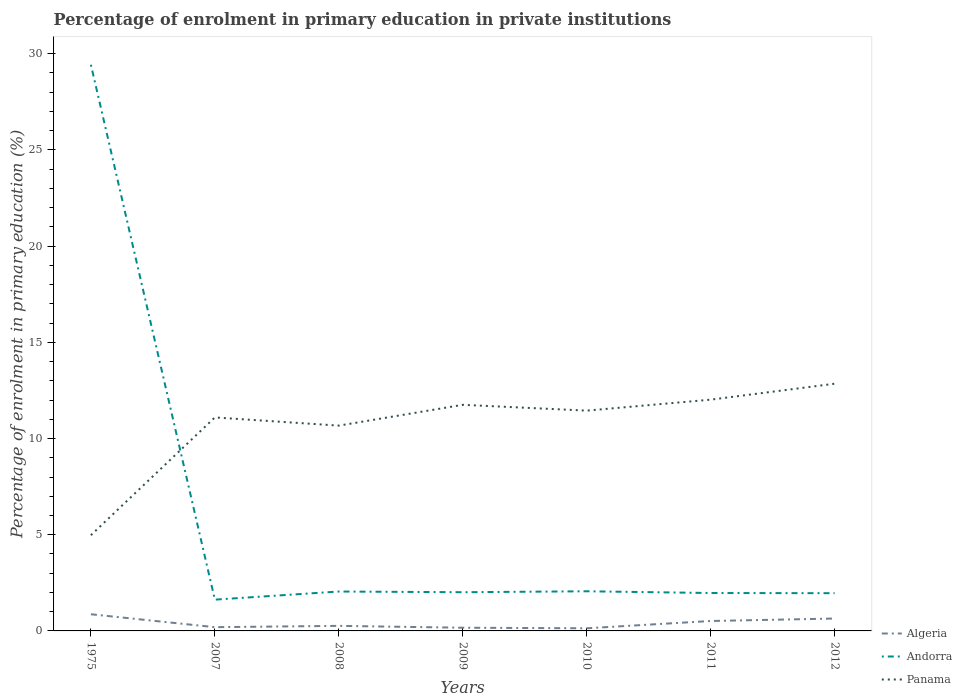Across all years, what is the maximum percentage of enrolment in primary education in Panama?
Your answer should be very brief. 4.98. In which year was the percentage of enrolment in primary education in Panama maximum?
Offer a very short reply. 1975. What is the total percentage of enrolment in primary education in Algeria in the graph?
Make the answer very short. -0.38. What is the difference between the highest and the second highest percentage of enrolment in primary education in Andorra?
Your answer should be compact. 27.8. What is the difference between the highest and the lowest percentage of enrolment in primary education in Panama?
Offer a very short reply. 5. Is the percentage of enrolment in primary education in Panama strictly greater than the percentage of enrolment in primary education in Algeria over the years?
Provide a succinct answer. No. Does the graph contain any zero values?
Make the answer very short. No. Does the graph contain grids?
Keep it short and to the point. No. Where does the legend appear in the graph?
Your response must be concise. Bottom right. What is the title of the graph?
Provide a short and direct response. Percentage of enrolment in primary education in private institutions. What is the label or title of the Y-axis?
Ensure brevity in your answer.  Percentage of enrolment in primary education (%). What is the Percentage of enrolment in primary education (%) in Algeria in 1975?
Ensure brevity in your answer.  0.87. What is the Percentage of enrolment in primary education (%) in Andorra in 1975?
Provide a succinct answer. 29.43. What is the Percentage of enrolment in primary education (%) in Panama in 1975?
Your answer should be compact. 4.98. What is the Percentage of enrolment in primary education (%) of Algeria in 2007?
Make the answer very short. 0.2. What is the Percentage of enrolment in primary education (%) in Andorra in 2007?
Keep it short and to the point. 1.63. What is the Percentage of enrolment in primary education (%) in Panama in 2007?
Give a very brief answer. 11.1. What is the Percentage of enrolment in primary education (%) of Algeria in 2008?
Ensure brevity in your answer.  0.26. What is the Percentage of enrolment in primary education (%) of Andorra in 2008?
Make the answer very short. 2.05. What is the Percentage of enrolment in primary education (%) in Panama in 2008?
Offer a very short reply. 10.67. What is the Percentage of enrolment in primary education (%) in Algeria in 2009?
Provide a short and direct response. 0.17. What is the Percentage of enrolment in primary education (%) of Andorra in 2009?
Your answer should be very brief. 2.01. What is the Percentage of enrolment in primary education (%) in Panama in 2009?
Provide a short and direct response. 11.75. What is the Percentage of enrolment in primary education (%) of Algeria in 2010?
Provide a succinct answer. 0.14. What is the Percentage of enrolment in primary education (%) in Andorra in 2010?
Keep it short and to the point. 2.06. What is the Percentage of enrolment in primary education (%) of Panama in 2010?
Your answer should be compact. 11.45. What is the Percentage of enrolment in primary education (%) in Algeria in 2011?
Your response must be concise. 0.52. What is the Percentage of enrolment in primary education (%) in Andorra in 2011?
Ensure brevity in your answer.  1.97. What is the Percentage of enrolment in primary education (%) of Panama in 2011?
Provide a succinct answer. 12.02. What is the Percentage of enrolment in primary education (%) of Algeria in 2012?
Keep it short and to the point. 0.64. What is the Percentage of enrolment in primary education (%) in Andorra in 2012?
Provide a succinct answer. 1.96. What is the Percentage of enrolment in primary education (%) in Panama in 2012?
Provide a succinct answer. 12.85. Across all years, what is the maximum Percentage of enrolment in primary education (%) in Algeria?
Offer a very short reply. 0.87. Across all years, what is the maximum Percentage of enrolment in primary education (%) in Andorra?
Your response must be concise. 29.43. Across all years, what is the maximum Percentage of enrolment in primary education (%) of Panama?
Offer a terse response. 12.85. Across all years, what is the minimum Percentage of enrolment in primary education (%) of Algeria?
Your response must be concise. 0.14. Across all years, what is the minimum Percentage of enrolment in primary education (%) of Andorra?
Keep it short and to the point. 1.63. Across all years, what is the minimum Percentage of enrolment in primary education (%) of Panama?
Your response must be concise. 4.98. What is the total Percentage of enrolment in primary education (%) of Algeria in the graph?
Provide a succinct answer. 2.79. What is the total Percentage of enrolment in primary education (%) in Andorra in the graph?
Your answer should be very brief. 41.11. What is the total Percentage of enrolment in primary education (%) of Panama in the graph?
Your answer should be compact. 74.82. What is the difference between the Percentage of enrolment in primary education (%) of Algeria in 1975 and that in 2007?
Your answer should be very brief. 0.67. What is the difference between the Percentage of enrolment in primary education (%) of Andorra in 1975 and that in 2007?
Your answer should be very brief. 27.8. What is the difference between the Percentage of enrolment in primary education (%) of Panama in 1975 and that in 2007?
Offer a very short reply. -6.12. What is the difference between the Percentage of enrolment in primary education (%) of Algeria in 1975 and that in 2008?
Offer a terse response. 0.6. What is the difference between the Percentage of enrolment in primary education (%) in Andorra in 1975 and that in 2008?
Your answer should be very brief. 27.38. What is the difference between the Percentage of enrolment in primary education (%) of Panama in 1975 and that in 2008?
Provide a short and direct response. -5.7. What is the difference between the Percentage of enrolment in primary education (%) in Algeria in 1975 and that in 2009?
Make the answer very short. 0.7. What is the difference between the Percentage of enrolment in primary education (%) of Andorra in 1975 and that in 2009?
Keep it short and to the point. 27.42. What is the difference between the Percentage of enrolment in primary education (%) of Panama in 1975 and that in 2009?
Provide a short and direct response. -6.78. What is the difference between the Percentage of enrolment in primary education (%) in Algeria in 1975 and that in 2010?
Give a very brief answer. 0.73. What is the difference between the Percentage of enrolment in primary education (%) of Andorra in 1975 and that in 2010?
Your response must be concise. 27.37. What is the difference between the Percentage of enrolment in primary education (%) of Panama in 1975 and that in 2010?
Provide a succinct answer. -6.47. What is the difference between the Percentage of enrolment in primary education (%) of Algeria in 1975 and that in 2011?
Keep it short and to the point. 0.35. What is the difference between the Percentage of enrolment in primary education (%) of Andorra in 1975 and that in 2011?
Offer a very short reply. 27.46. What is the difference between the Percentage of enrolment in primary education (%) in Panama in 1975 and that in 2011?
Your answer should be compact. -7.04. What is the difference between the Percentage of enrolment in primary education (%) of Algeria in 1975 and that in 2012?
Ensure brevity in your answer.  0.22. What is the difference between the Percentage of enrolment in primary education (%) in Andorra in 1975 and that in 2012?
Keep it short and to the point. 27.47. What is the difference between the Percentage of enrolment in primary education (%) in Panama in 1975 and that in 2012?
Your answer should be compact. -7.87. What is the difference between the Percentage of enrolment in primary education (%) in Algeria in 2007 and that in 2008?
Keep it short and to the point. -0.07. What is the difference between the Percentage of enrolment in primary education (%) in Andorra in 2007 and that in 2008?
Offer a very short reply. -0.42. What is the difference between the Percentage of enrolment in primary education (%) of Panama in 2007 and that in 2008?
Your answer should be compact. 0.43. What is the difference between the Percentage of enrolment in primary education (%) of Algeria in 2007 and that in 2009?
Ensure brevity in your answer.  0.03. What is the difference between the Percentage of enrolment in primary education (%) of Andorra in 2007 and that in 2009?
Your answer should be very brief. -0.39. What is the difference between the Percentage of enrolment in primary education (%) of Panama in 2007 and that in 2009?
Offer a terse response. -0.66. What is the difference between the Percentage of enrolment in primary education (%) in Algeria in 2007 and that in 2010?
Offer a very short reply. 0.06. What is the difference between the Percentage of enrolment in primary education (%) in Andorra in 2007 and that in 2010?
Provide a succinct answer. -0.43. What is the difference between the Percentage of enrolment in primary education (%) of Panama in 2007 and that in 2010?
Make the answer very short. -0.35. What is the difference between the Percentage of enrolment in primary education (%) of Algeria in 2007 and that in 2011?
Keep it short and to the point. -0.32. What is the difference between the Percentage of enrolment in primary education (%) of Andorra in 2007 and that in 2011?
Offer a very short reply. -0.34. What is the difference between the Percentage of enrolment in primary education (%) in Panama in 2007 and that in 2011?
Offer a terse response. -0.92. What is the difference between the Percentage of enrolment in primary education (%) in Algeria in 2007 and that in 2012?
Keep it short and to the point. -0.45. What is the difference between the Percentage of enrolment in primary education (%) in Andorra in 2007 and that in 2012?
Keep it short and to the point. -0.33. What is the difference between the Percentage of enrolment in primary education (%) of Panama in 2007 and that in 2012?
Give a very brief answer. -1.75. What is the difference between the Percentage of enrolment in primary education (%) in Algeria in 2008 and that in 2009?
Offer a terse response. 0.1. What is the difference between the Percentage of enrolment in primary education (%) of Andorra in 2008 and that in 2009?
Provide a short and direct response. 0.04. What is the difference between the Percentage of enrolment in primary education (%) in Panama in 2008 and that in 2009?
Your answer should be compact. -1.08. What is the difference between the Percentage of enrolment in primary education (%) in Algeria in 2008 and that in 2010?
Offer a terse response. 0.13. What is the difference between the Percentage of enrolment in primary education (%) of Andorra in 2008 and that in 2010?
Offer a terse response. -0.01. What is the difference between the Percentage of enrolment in primary education (%) of Panama in 2008 and that in 2010?
Give a very brief answer. -0.78. What is the difference between the Percentage of enrolment in primary education (%) in Algeria in 2008 and that in 2011?
Give a very brief answer. -0.25. What is the difference between the Percentage of enrolment in primary education (%) of Andorra in 2008 and that in 2011?
Provide a short and direct response. 0.08. What is the difference between the Percentage of enrolment in primary education (%) in Panama in 2008 and that in 2011?
Your response must be concise. -1.35. What is the difference between the Percentage of enrolment in primary education (%) in Algeria in 2008 and that in 2012?
Your answer should be very brief. -0.38. What is the difference between the Percentage of enrolment in primary education (%) of Andorra in 2008 and that in 2012?
Your answer should be compact. 0.09. What is the difference between the Percentage of enrolment in primary education (%) in Panama in 2008 and that in 2012?
Provide a short and direct response. -2.18. What is the difference between the Percentage of enrolment in primary education (%) in Algeria in 2009 and that in 2010?
Make the answer very short. 0.03. What is the difference between the Percentage of enrolment in primary education (%) of Andorra in 2009 and that in 2010?
Offer a terse response. -0.05. What is the difference between the Percentage of enrolment in primary education (%) of Panama in 2009 and that in 2010?
Offer a terse response. 0.3. What is the difference between the Percentage of enrolment in primary education (%) in Algeria in 2009 and that in 2011?
Offer a very short reply. -0.35. What is the difference between the Percentage of enrolment in primary education (%) in Andorra in 2009 and that in 2011?
Keep it short and to the point. 0.04. What is the difference between the Percentage of enrolment in primary education (%) of Panama in 2009 and that in 2011?
Give a very brief answer. -0.27. What is the difference between the Percentage of enrolment in primary education (%) in Algeria in 2009 and that in 2012?
Make the answer very short. -0.48. What is the difference between the Percentage of enrolment in primary education (%) of Andorra in 2009 and that in 2012?
Provide a short and direct response. 0.05. What is the difference between the Percentage of enrolment in primary education (%) in Panama in 2009 and that in 2012?
Give a very brief answer. -1.1. What is the difference between the Percentage of enrolment in primary education (%) in Algeria in 2010 and that in 2011?
Offer a terse response. -0.38. What is the difference between the Percentage of enrolment in primary education (%) of Andorra in 2010 and that in 2011?
Offer a terse response. 0.09. What is the difference between the Percentage of enrolment in primary education (%) of Panama in 2010 and that in 2011?
Ensure brevity in your answer.  -0.57. What is the difference between the Percentage of enrolment in primary education (%) in Algeria in 2010 and that in 2012?
Provide a succinct answer. -0.51. What is the difference between the Percentage of enrolment in primary education (%) of Andorra in 2010 and that in 2012?
Offer a very short reply. 0.1. What is the difference between the Percentage of enrolment in primary education (%) in Panama in 2010 and that in 2012?
Your response must be concise. -1.4. What is the difference between the Percentage of enrolment in primary education (%) of Algeria in 2011 and that in 2012?
Your response must be concise. -0.13. What is the difference between the Percentage of enrolment in primary education (%) of Andorra in 2011 and that in 2012?
Ensure brevity in your answer.  0.01. What is the difference between the Percentage of enrolment in primary education (%) in Panama in 2011 and that in 2012?
Offer a terse response. -0.83. What is the difference between the Percentage of enrolment in primary education (%) in Algeria in 1975 and the Percentage of enrolment in primary education (%) in Andorra in 2007?
Offer a very short reply. -0.76. What is the difference between the Percentage of enrolment in primary education (%) in Algeria in 1975 and the Percentage of enrolment in primary education (%) in Panama in 2007?
Give a very brief answer. -10.23. What is the difference between the Percentage of enrolment in primary education (%) of Andorra in 1975 and the Percentage of enrolment in primary education (%) of Panama in 2007?
Keep it short and to the point. 18.33. What is the difference between the Percentage of enrolment in primary education (%) of Algeria in 1975 and the Percentage of enrolment in primary education (%) of Andorra in 2008?
Offer a terse response. -1.18. What is the difference between the Percentage of enrolment in primary education (%) in Algeria in 1975 and the Percentage of enrolment in primary education (%) in Panama in 2008?
Keep it short and to the point. -9.8. What is the difference between the Percentage of enrolment in primary education (%) in Andorra in 1975 and the Percentage of enrolment in primary education (%) in Panama in 2008?
Keep it short and to the point. 18.76. What is the difference between the Percentage of enrolment in primary education (%) of Algeria in 1975 and the Percentage of enrolment in primary education (%) of Andorra in 2009?
Make the answer very short. -1.15. What is the difference between the Percentage of enrolment in primary education (%) of Algeria in 1975 and the Percentage of enrolment in primary education (%) of Panama in 2009?
Your answer should be very brief. -10.89. What is the difference between the Percentage of enrolment in primary education (%) of Andorra in 1975 and the Percentage of enrolment in primary education (%) of Panama in 2009?
Provide a short and direct response. 17.68. What is the difference between the Percentage of enrolment in primary education (%) of Algeria in 1975 and the Percentage of enrolment in primary education (%) of Andorra in 2010?
Your answer should be compact. -1.19. What is the difference between the Percentage of enrolment in primary education (%) of Algeria in 1975 and the Percentage of enrolment in primary education (%) of Panama in 2010?
Keep it short and to the point. -10.58. What is the difference between the Percentage of enrolment in primary education (%) in Andorra in 1975 and the Percentage of enrolment in primary education (%) in Panama in 2010?
Give a very brief answer. 17.98. What is the difference between the Percentage of enrolment in primary education (%) in Algeria in 1975 and the Percentage of enrolment in primary education (%) in Andorra in 2011?
Your answer should be compact. -1.1. What is the difference between the Percentage of enrolment in primary education (%) of Algeria in 1975 and the Percentage of enrolment in primary education (%) of Panama in 2011?
Make the answer very short. -11.15. What is the difference between the Percentage of enrolment in primary education (%) of Andorra in 1975 and the Percentage of enrolment in primary education (%) of Panama in 2011?
Keep it short and to the point. 17.41. What is the difference between the Percentage of enrolment in primary education (%) of Algeria in 1975 and the Percentage of enrolment in primary education (%) of Andorra in 2012?
Your answer should be very brief. -1.09. What is the difference between the Percentage of enrolment in primary education (%) of Algeria in 1975 and the Percentage of enrolment in primary education (%) of Panama in 2012?
Your response must be concise. -11.98. What is the difference between the Percentage of enrolment in primary education (%) in Andorra in 1975 and the Percentage of enrolment in primary education (%) in Panama in 2012?
Keep it short and to the point. 16.58. What is the difference between the Percentage of enrolment in primary education (%) in Algeria in 2007 and the Percentage of enrolment in primary education (%) in Andorra in 2008?
Your answer should be compact. -1.85. What is the difference between the Percentage of enrolment in primary education (%) in Algeria in 2007 and the Percentage of enrolment in primary education (%) in Panama in 2008?
Your answer should be very brief. -10.48. What is the difference between the Percentage of enrolment in primary education (%) in Andorra in 2007 and the Percentage of enrolment in primary education (%) in Panama in 2008?
Offer a terse response. -9.04. What is the difference between the Percentage of enrolment in primary education (%) in Algeria in 2007 and the Percentage of enrolment in primary education (%) in Andorra in 2009?
Offer a very short reply. -1.82. What is the difference between the Percentage of enrolment in primary education (%) in Algeria in 2007 and the Percentage of enrolment in primary education (%) in Panama in 2009?
Your answer should be compact. -11.56. What is the difference between the Percentage of enrolment in primary education (%) in Andorra in 2007 and the Percentage of enrolment in primary education (%) in Panama in 2009?
Provide a succinct answer. -10.13. What is the difference between the Percentage of enrolment in primary education (%) of Algeria in 2007 and the Percentage of enrolment in primary education (%) of Andorra in 2010?
Make the answer very short. -1.87. What is the difference between the Percentage of enrolment in primary education (%) in Algeria in 2007 and the Percentage of enrolment in primary education (%) in Panama in 2010?
Provide a succinct answer. -11.26. What is the difference between the Percentage of enrolment in primary education (%) of Andorra in 2007 and the Percentage of enrolment in primary education (%) of Panama in 2010?
Your answer should be compact. -9.82. What is the difference between the Percentage of enrolment in primary education (%) of Algeria in 2007 and the Percentage of enrolment in primary education (%) of Andorra in 2011?
Offer a terse response. -1.78. What is the difference between the Percentage of enrolment in primary education (%) in Algeria in 2007 and the Percentage of enrolment in primary education (%) in Panama in 2011?
Your answer should be very brief. -11.83. What is the difference between the Percentage of enrolment in primary education (%) of Andorra in 2007 and the Percentage of enrolment in primary education (%) of Panama in 2011?
Your response must be concise. -10.39. What is the difference between the Percentage of enrolment in primary education (%) in Algeria in 2007 and the Percentage of enrolment in primary education (%) in Andorra in 2012?
Your response must be concise. -1.77. What is the difference between the Percentage of enrolment in primary education (%) of Algeria in 2007 and the Percentage of enrolment in primary education (%) of Panama in 2012?
Provide a short and direct response. -12.65. What is the difference between the Percentage of enrolment in primary education (%) in Andorra in 2007 and the Percentage of enrolment in primary education (%) in Panama in 2012?
Offer a terse response. -11.22. What is the difference between the Percentage of enrolment in primary education (%) in Algeria in 2008 and the Percentage of enrolment in primary education (%) in Andorra in 2009?
Keep it short and to the point. -1.75. What is the difference between the Percentage of enrolment in primary education (%) in Algeria in 2008 and the Percentage of enrolment in primary education (%) in Panama in 2009?
Provide a short and direct response. -11.49. What is the difference between the Percentage of enrolment in primary education (%) in Andorra in 2008 and the Percentage of enrolment in primary education (%) in Panama in 2009?
Make the answer very short. -9.7. What is the difference between the Percentage of enrolment in primary education (%) of Algeria in 2008 and the Percentage of enrolment in primary education (%) of Andorra in 2010?
Provide a succinct answer. -1.8. What is the difference between the Percentage of enrolment in primary education (%) in Algeria in 2008 and the Percentage of enrolment in primary education (%) in Panama in 2010?
Provide a succinct answer. -11.19. What is the difference between the Percentage of enrolment in primary education (%) in Andorra in 2008 and the Percentage of enrolment in primary education (%) in Panama in 2010?
Your answer should be very brief. -9.4. What is the difference between the Percentage of enrolment in primary education (%) of Algeria in 2008 and the Percentage of enrolment in primary education (%) of Andorra in 2011?
Your response must be concise. -1.71. What is the difference between the Percentage of enrolment in primary education (%) in Algeria in 2008 and the Percentage of enrolment in primary education (%) in Panama in 2011?
Offer a very short reply. -11.76. What is the difference between the Percentage of enrolment in primary education (%) in Andorra in 2008 and the Percentage of enrolment in primary education (%) in Panama in 2011?
Provide a succinct answer. -9.97. What is the difference between the Percentage of enrolment in primary education (%) of Algeria in 2008 and the Percentage of enrolment in primary education (%) of Andorra in 2012?
Provide a short and direct response. -1.7. What is the difference between the Percentage of enrolment in primary education (%) of Algeria in 2008 and the Percentage of enrolment in primary education (%) of Panama in 2012?
Provide a short and direct response. -12.59. What is the difference between the Percentage of enrolment in primary education (%) in Andorra in 2008 and the Percentage of enrolment in primary education (%) in Panama in 2012?
Your response must be concise. -10.8. What is the difference between the Percentage of enrolment in primary education (%) of Algeria in 2009 and the Percentage of enrolment in primary education (%) of Andorra in 2010?
Ensure brevity in your answer.  -1.89. What is the difference between the Percentage of enrolment in primary education (%) in Algeria in 2009 and the Percentage of enrolment in primary education (%) in Panama in 2010?
Ensure brevity in your answer.  -11.28. What is the difference between the Percentage of enrolment in primary education (%) in Andorra in 2009 and the Percentage of enrolment in primary education (%) in Panama in 2010?
Provide a short and direct response. -9.44. What is the difference between the Percentage of enrolment in primary education (%) of Algeria in 2009 and the Percentage of enrolment in primary education (%) of Andorra in 2011?
Make the answer very short. -1.8. What is the difference between the Percentage of enrolment in primary education (%) in Algeria in 2009 and the Percentage of enrolment in primary education (%) in Panama in 2011?
Give a very brief answer. -11.85. What is the difference between the Percentage of enrolment in primary education (%) of Andorra in 2009 and the Percentage of enrolment in primary education (%) of Panama in 2011?
Offer a terse response. -10.01. What is the difference between the Percentage of enrolment in primary education (%) in Algeria in 2009 and the Percentage of enrolment in primary education (%) in Andorra in 2012?
Keep it short and to the point. -1.8. What is the difference between the Percentage of enrolment in primary education (%) of Algeria in 2009 and the Percentage of enrolment in primary education (%) of Panama in 2012?
Give a very brief answer. -12.68. What is the difference between the Percentage of enrolment in primary education (%) of Andorra in 2009 and the Percentage of enrolment in primary education (%) of Panama in 2012?
Keep it short and to the point. -10.84. What is the difference between the Percentage of enrolment in primary education (%) of Algeria in 2010 and the Percentage of enrolment in primary education (%) of Andorra in 2011?
Your answer should be compact. -1.83. What is the difference between the Percentage of enrolment in primary education (%) in Algeria in 2010 and the Percentage of enrolment in primary education (%) in Panama in 2011?
Your response must be concise. -11.88. What is the difference between the Percentage of enrolment in primary education (%) of Andorra in 2010 and the Percentage of enrolment in primary education (%) of Panama in 2011?
Keep it short and to the point. -9.96. What is the difference between the Percentage of enrolment in primary education (%) of Algeria in 2010 and the Percentage of enrolment in primary education (%) of Andorra in 2012?
Your answer should be compact. -1.82. What is the difference between the Percentage of enrolment in primary education (%) of Algeria in 2010 and the Percentage of enrolment in primary education (%) of Panama in 2012?
Provide a short and direct response. -12.71. What is the difference between the Percentage of enrolment in primary education (%) of Andorra in 2010 and the Percentage of enrolment in primary education (%) of Panama in 2012?
Offer a very short reply. -10.79. What is the difference between the Percentage of enrolment in primary education (%) of Algeria in 2011 and the Percentage of enrolment in primary education (%) of Andorra in 2012?
Offer a terse response. -1.45. What is the difference between the Percentage of enrolment in primary education (%) of Algeria in 2011 and the Percentage of enrolment in primary education (%) of Panama in 2012?
Ensure brevity in your answer.  -12.33. What is the difference between the Percentage of enrolment in primary education (%) in Andorra in 2011 and the Percentage of enrolment in primary education (%) in Panama in 2012?
Your answer should be compact. -10.88. What is the average Percentage of enrolment in primary education (%) of Algeria per year?
Provide a short and direct response. 0.4. What is the average Percentage of enrolment in primary education (%) of Andorra per year?
Ensure brevity in your answer.  5.87. What is the average Percentage of enrolment in primary education (%) in Panama per year?
Make the answer very short. 10.69. In the year 1975, what is the difference between the Percentage of enrolment in primary education (%) of Algeria and Percentage of enrolment in primary education (%) of Andorra?
Your answer should be very brief. -28.56. In the year 1975, what is the difference between the Percentage of enrolment in primary education (%) of Algeria and Percentage of enrolment in primary education (%) of Panama?
Keep it short and to the point. -4.11. In the year 1975, what is the difference between the Percentage of enrolment in primary education (%) in Andorra and Percentage of enrolment in primary education (%) in Panama?
Provide a short and direct response. 24.45. In the year 2007, what is the difference between the Percentage of enrolment in primary education (%) in Algeria and Percentage of enrolment in primary education (%) in Andorra?
Offer a terse response. -1.43. In the year 2007, what is the difference between the Percentage of enrolment in primary education (%) of Algeria and Percentage of enrolment in primary education (%) of Panama?
Ensure brevity in your answer.  -10.9. In the year 2007, what is the difference between the Percentage of enrolment in primary education (%) of Andorra and Percentage of enrolment in primary education (%) of Panama?
Make the answer very short. -9.47. In the year 2008, what is the difference between the Percentage of enrolment in primary education (%) of Algeria and Percentage of enrolment in primary education (%) of Andorra?
Your response must be concise. -1.79. In the year 2008, what is the difference between the Percentage of enrolment in primary education (%) of Algeria and Percentage of enrolment in primary education (%) of Panama?
Make the answer very short. -10.41. In the year 2008, what is the difference between the Percentage of enrolment in primary education (%) of Andorra and Percentage of enrolment in primary education (%) of Panama?
Provide a short and direct response. -8.62. In the year 2009, what is the difference between the Percentage of enrolment in primary education (%) in Algeria and Percentage of enrolment in primary education (%) in Andorra?
Offer a very short reply. -1.85. In the year 2009, what is the difference between the Percentage of enrolment in primary education (%) in Algeria and Percentage of enrolment in primary education (%) in Panama?
Your response must be concise. -11.59. In the year 2009, what is the difference between the Percentage of enrolment in primary education (%) of Andorra and Percentage of enrolment in primary education (%) of Panama?
Keep it short and to the point. -9.74. In the year 2010, what is the difference between the Percentage of enrolment in primary education (%) of Algeria and Percentage of enrolment in primary education (%) of Andorra?
Your response must be concise. -1.92. In the year 2010, what is the difference between the Percentage of enrolment in primary education (%) in Algeria and Percentage of enrolment in primary education (%) in Panama?
Provide a succinct answer. -11.31. In the year 2010, what is the difference between the Percentage of enrolment in primary education (%) in Andorra and Percentage of enrolment in primary education (%) in Panama?
Give a very brief answer. -9.39. In the year 2011, what is the difference between the Percentage of enrolment in primary education (%) of Algeria and Percentage of enrolment in primary education (%) of Andorra?
Provide a short and direct response. -1.45. In the year 2011, what is the difference between the Percentage of enrolment in primary education (%) in Algeria and Percentage of enrolment in primary education (%) in Panama?
Provide a short and direct response. -11.5. In the year 2011, what is the difference between the Percentage of enrolment in primary education (%) in Andorra and Percentage of enrolment in primary education (%) in Panama?
Offer a terse response. -10.05. In the year 2012, what is the difference between the Percentage of enrolment in primary education (%) in Algeria and Percentage of enrolment in primary education (%) in Andorra?
Keep it short and to the point. -1.32. In the year 2012, what is the difference between the Percentage of enrolment in primary education (%) of Algeria and Percentage of enrolment in primary education (%) of Panama?
Ensure brevity in your answer.  -12.2. In the year 2012, what is the difference between the Percentage of enrolment in primary education (%) in Andorra and Percentage of enrolment in primary education (%) in Panama?
Keep it short and to the point. -10.89. What is the ratio of the Percentage of enrolment in primary education (%) of Algeria in 1975 to that in 2007?
Provide a short and direct response. 4.44. What is the ratio of the Percentage of enrolment in primary education (%) in Andorra in 1975 to that in 2007?
Provide a short and direct response. 18.09. What is the ratio of the Percentage of enrolment in primary education (%) in Panama in 1975 to that in 2007?
Keep it short and to the point. 0.45. What is the ratio of the Percentage of enrolment in primary education (%) of Algeria in 1975 to that in 2008?
Provide a succinct answer. 3.29. What is the ratio of the Percentage of enrolment in primary education (%) of Andorra in 1975 to that in 2008?
Offer a terse response. 14.37. What is the ratio of the Percentage of enrolment in primary education (%) of Panama in 1975 to that in 2008?
Give a very brief answer. 0.47. What is the ratio of the Percentage of enrolment in primary education (%) in Algeria in 1975 to that in 2009?
Keep it short and to the point. 5.21. What is the ratio of the Percentage of enrolment in primary education (%) of Andorra in 1975 to that in 2009?
Offer a terse response. 14.63. What is the ratio of the Percentage of enrolment in primary education (%) of Panama in 1975 to that in 2009?
Offer a very short reply. 0.42. What is the ratio of the Percentage of enrolment in primary education (%) in Algeria in 1975 to that in 2010?
Ensure brevity in your answer.  6.33. What is the ratio of the Percentage of enrolment in primary education (%) in Andorra in 1975 to that in 2010?
Make the answer very short. 14.28. What is the ratio of the Percentage of enrolment in primary education (%) in Panama in 1975 to that in 2010?
Ensure brevity in your answer.  0.43. What is the ratio of the Percentage of enrolment in primary education (%) in Algeria in 1975 to that in 2011?
Your answer should be compact. 1.68. What is the ratio of the Percentage of enrolment in primary education (%) of Andorra in 1975 to that in 2011?
Your answer should be very brief. 14.93. What is the ratio of the Percentage of enrolment in primary education (%) in Panama in 1975 to that in 2011?
Offer a terse response. 0.41. What is the ratio of the Percentage of enrolment in primary education (%) of Algeria in 1975 to that in 2012?
Ensure brevity in your answer.  1.35. What is the ratio of the Percentage of enrolment in primary education (%) in Andorra in 1975 to that in 2012?
Offer a very short reply. 15. What is the ratio of the Percentage of enrolment in primary education (%) of Panama in 1975 to that in 2012?
Offer a very short reply. 0.39. What is the ratio of the Percentage of enrolment in primary education (%) in Algeria in 2007 to that in 2008?
Offer a terse response. 0.74. What is the ratio of the Percentage of enrolment in primary education (%) of Andorra in 2007 to that in 2008?
Your answer should be very brief. 0.79. What is the ratio of the Percentage of enrolment in primary education (%) of Panama in 2007 to that in 2008?
Provide a succinct answer. 1.04. What is the ratio of the Percentage of enrolment in primary education (%) in Algeria in 2007 to that in 2009?
Offer a terse response. 1.17. What is the ratio of the Percentage of enrolment in primary education (%) of Andorra in 2007 to that in 2009?
Provide a short and direct response. 0.81. What is the ratio of the Percentage of enrolment in primary education (%) in Panama in 2007 to that in 2009?
Keep it short and to the point. 0.94. What is the ratio of the Percentage of enrolment in primary education (%) in Algeria in 2007 to that in 2010?
Your answer should be very brief. 1.43. What is the ratio of the Percentage of enrolment in primary education (%) of Andorra in 2007 to that in 2010?
Offer a terse response. 0.79. What is the ratio of the Percentage of enrolment in primary education (%) in Panama in 2007 to that in 2010?
Ensure brevity in your answer.  0.97. What is the ratio of the Percentage of enrolment in primary education (%) in Algeria in 2007 to that in 2011?
Offer a terse response. 0.38. What is the ratio of the Percentage of enrolment in primary education (%) of Andorra in 2007 to that in 2011?
Provide a succinct answer. 0.83. What is the ratio of the Percentage of enrolment in primary education (%) of Panama in 2007 to that in 2011?
Provide a short and direct response. 0.92. What is the ratio of the Percentage of enrolment in primary education (%) in Algeria in 2007 to that in 2012?
Your response must be concise. 0.3. What is the ratio of the Percentage of enrolment in primary education (%) in Andorra in 2007 to that in 2012?
Keep it short and to the point. 0.83. What is the ratio of the Percentage of enrolment in primary education (%) of Panama in 2007 to that in 2012?
Offer a terse response. 0.86. What is the ratio of the Percentage of enrolment in primary education (%) of Algeria in 2008 to that in 2009?
Give a very brief answer. 1.58. What is the ratio of the Percentage of enrolment in primary education (%) of Andorra in 2008 to that in 2009?
Ensure brevity in your answer.  1.02. What is the ratio of the Percentage of enrolment in primary education (%) in Panama in 2008 to that in 2009?
Make the answer very short. 0.91. What is the ratio of the Percentage of enrolment in primary education (%) in Algeria in 2008 to that in 2010?
Provide a short and direct response. 1.92. What is the ratio of the Percentage of enrolment in primary education (%) in Panama in 2008 to that in 2010?
Your answer should be compact. 0.93. What is the ratio of the Percentage of enrolment in primary education (%) of Algeria in 2008 to that in 2011?
Keep it short and to the point. 0.51. What is the ratio of the Percentage of enrolment in primary education (%) in Andorra in 2008 to that in 2011?
Offer a very short reply. 1.04. What is the ratio of the Percentage of enrolment in primary education (%) in Panama in 2008 to that in 2011?
Give a very brief answer. 0.89. What is the ratio of the Percentage of enrolment in primary education (%) in Algeria in 2008 to that in 2012?
Your answer should be very brief. 0.41. What is the ratio of the Percentage of enrolment in primary education (%) of Andorra in 2008 to that in 2012?
Provide a succinct answer. 1.04. What is the ratio of the Percentage of enrolment in primary education (%) of Panama in 2008 to that in 2012?
Keep it short and to the point. 0.83. What is the ratio of the Percentage of enrolment in primary education (%) in Algeria in 2009 to that in 2010?
Your response must be concise. 1.22. What is the ratio of the Percentage of enrolment in primary education (%) of Andorra in 2009 to that in 2010?
Your answer should be very brief. 0.98. What is the ratio of the Percentage of enrolment in primary education (%) of Panama in 2009 to that in 2010?
Your answer should be very brief. 1.03. What is the ratio of the Percentage of enrolment in primary education (%) in Algeria in 2009 to that in 2011?
Offer a very short reply. 0.32. What is the ratio of the Percentage of enrolment in primary education (%) of Andorra in 2009 to that in 2011?
Ensure brevity in your answer.  1.02. What is the ratio of the Percentage of enrolment in primary education (%) in Panama in 2009 to that in 2011?
Ensure brevity in your answer.  0.98. What is the ratio of the Percentage of enrolment in primary education (%) of Algeria in 2009 to that in 2012?
Offer a terse response. 0.26. What is the ratio of the Percentage of enrolment in primary education (%) in Andorra in 2009 to that in 2012?
Offer a terse response. 1.03. What is the ratio of the Percentage of enrolment in primary education (%) of Panama in 2009 to that in 2012?
Provide a short and direct response. 0.91. What is the ratio of the Percentage of enrolment in primary education (%) of Algeria in 2010 to that in 2011?
Provide a succinct answer. 0.27. What is the ratio of the Percentage of enrolment in primary education (%) in Andorra in 2010 to that in 2011?
Give a very brief answer. 1.05. What is the ratio of the Percentage of enrolment in primary education (%) of Panama in 2010 to that in 2011?
Give a very brief answer. 0.95. What is the ratio of the Percentage of enrolment in primary education (%) of Algeria in 2010 to that in 2012?
Give a very brief answer. 0.21. What is the ratio of the Percentage of enrolment in primary education (%) in Andorra in 2010 to that in 2012?
Your answer should be very brief. 1.05. What is the ratio of the Percentage of enrolment in primary education (%) of Panama in 2010 to that in 2012?
Offer a terse response. 0.89. What is the ratio of the Percentage of enrolment in primary education (%) in Algeria in 2011 to that in 2012?
Keep it short and to the point. 0.8. What is the ratio of the Percentage of enrolment in primary education (%) in Andorra in 2011 to that in 2012?
Provide a short and direct response. 1. What is the ratio of the Percentage of enrolment in primary education (%) of Panama in 2011 to that in 2012?
Give a very brief answer. 0.94. What is the difference between the highest and the second highest Percentage of enrolment in primary education (%) in Algeria?
Offer a terse response. 0.22. What is the difference between the highest and the second highest Percentage of enrolment in primary education (%) in Andorra?
Offer a very short reply. 27.37. What is the difference between the highest and the second highest Percentage of enrolment in primary education (%) in Panama?
Offer a terse response. 0.83. What is the difference between the highest and the lowest Percentage of enrolment in primary education (%) of Algeria?
Offer a terse response. 0.73. What is the difference between the highest and the lowest Percentage of enrolment in primary education (%) of Andorra?
Offer a terse response. 27.8. What is the difference between the highest and the lowest Percentage of enrolment in primary education (%) of Panama?
Provide a succinct answer. 7.87. 